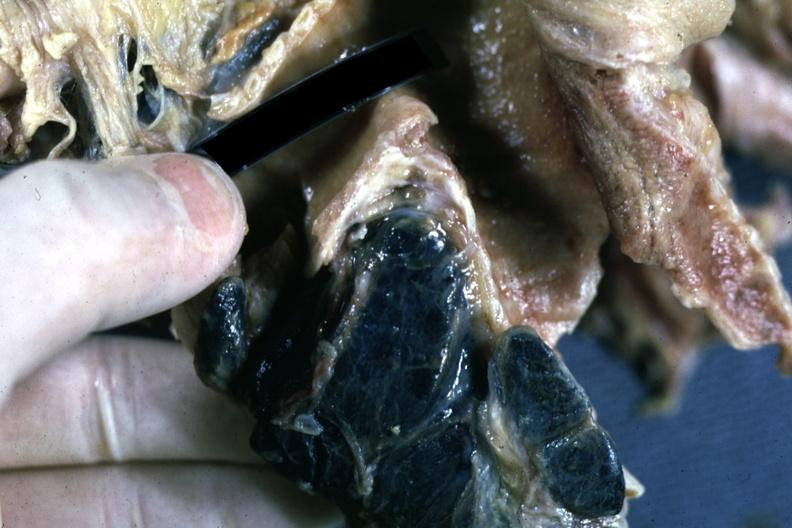s stillborn macerated present?
Answer the question using a single word or phrase. No 